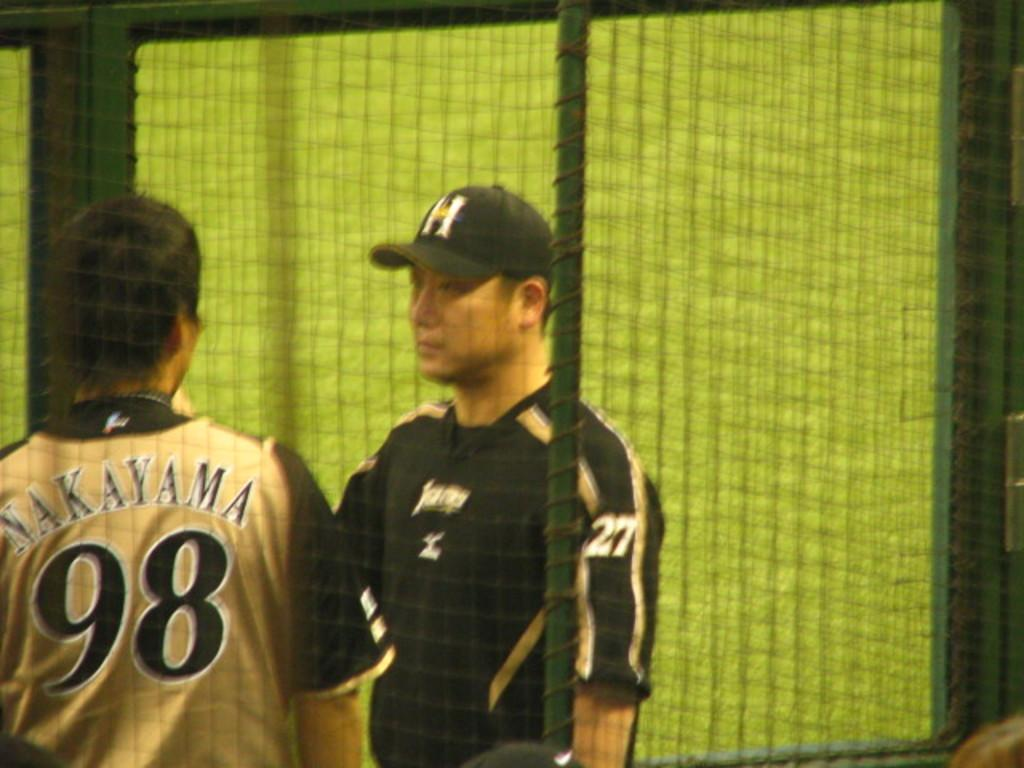Provide a one-sentence caption for the provided image. Opposing players number 98 and 27 are having a conversation. 